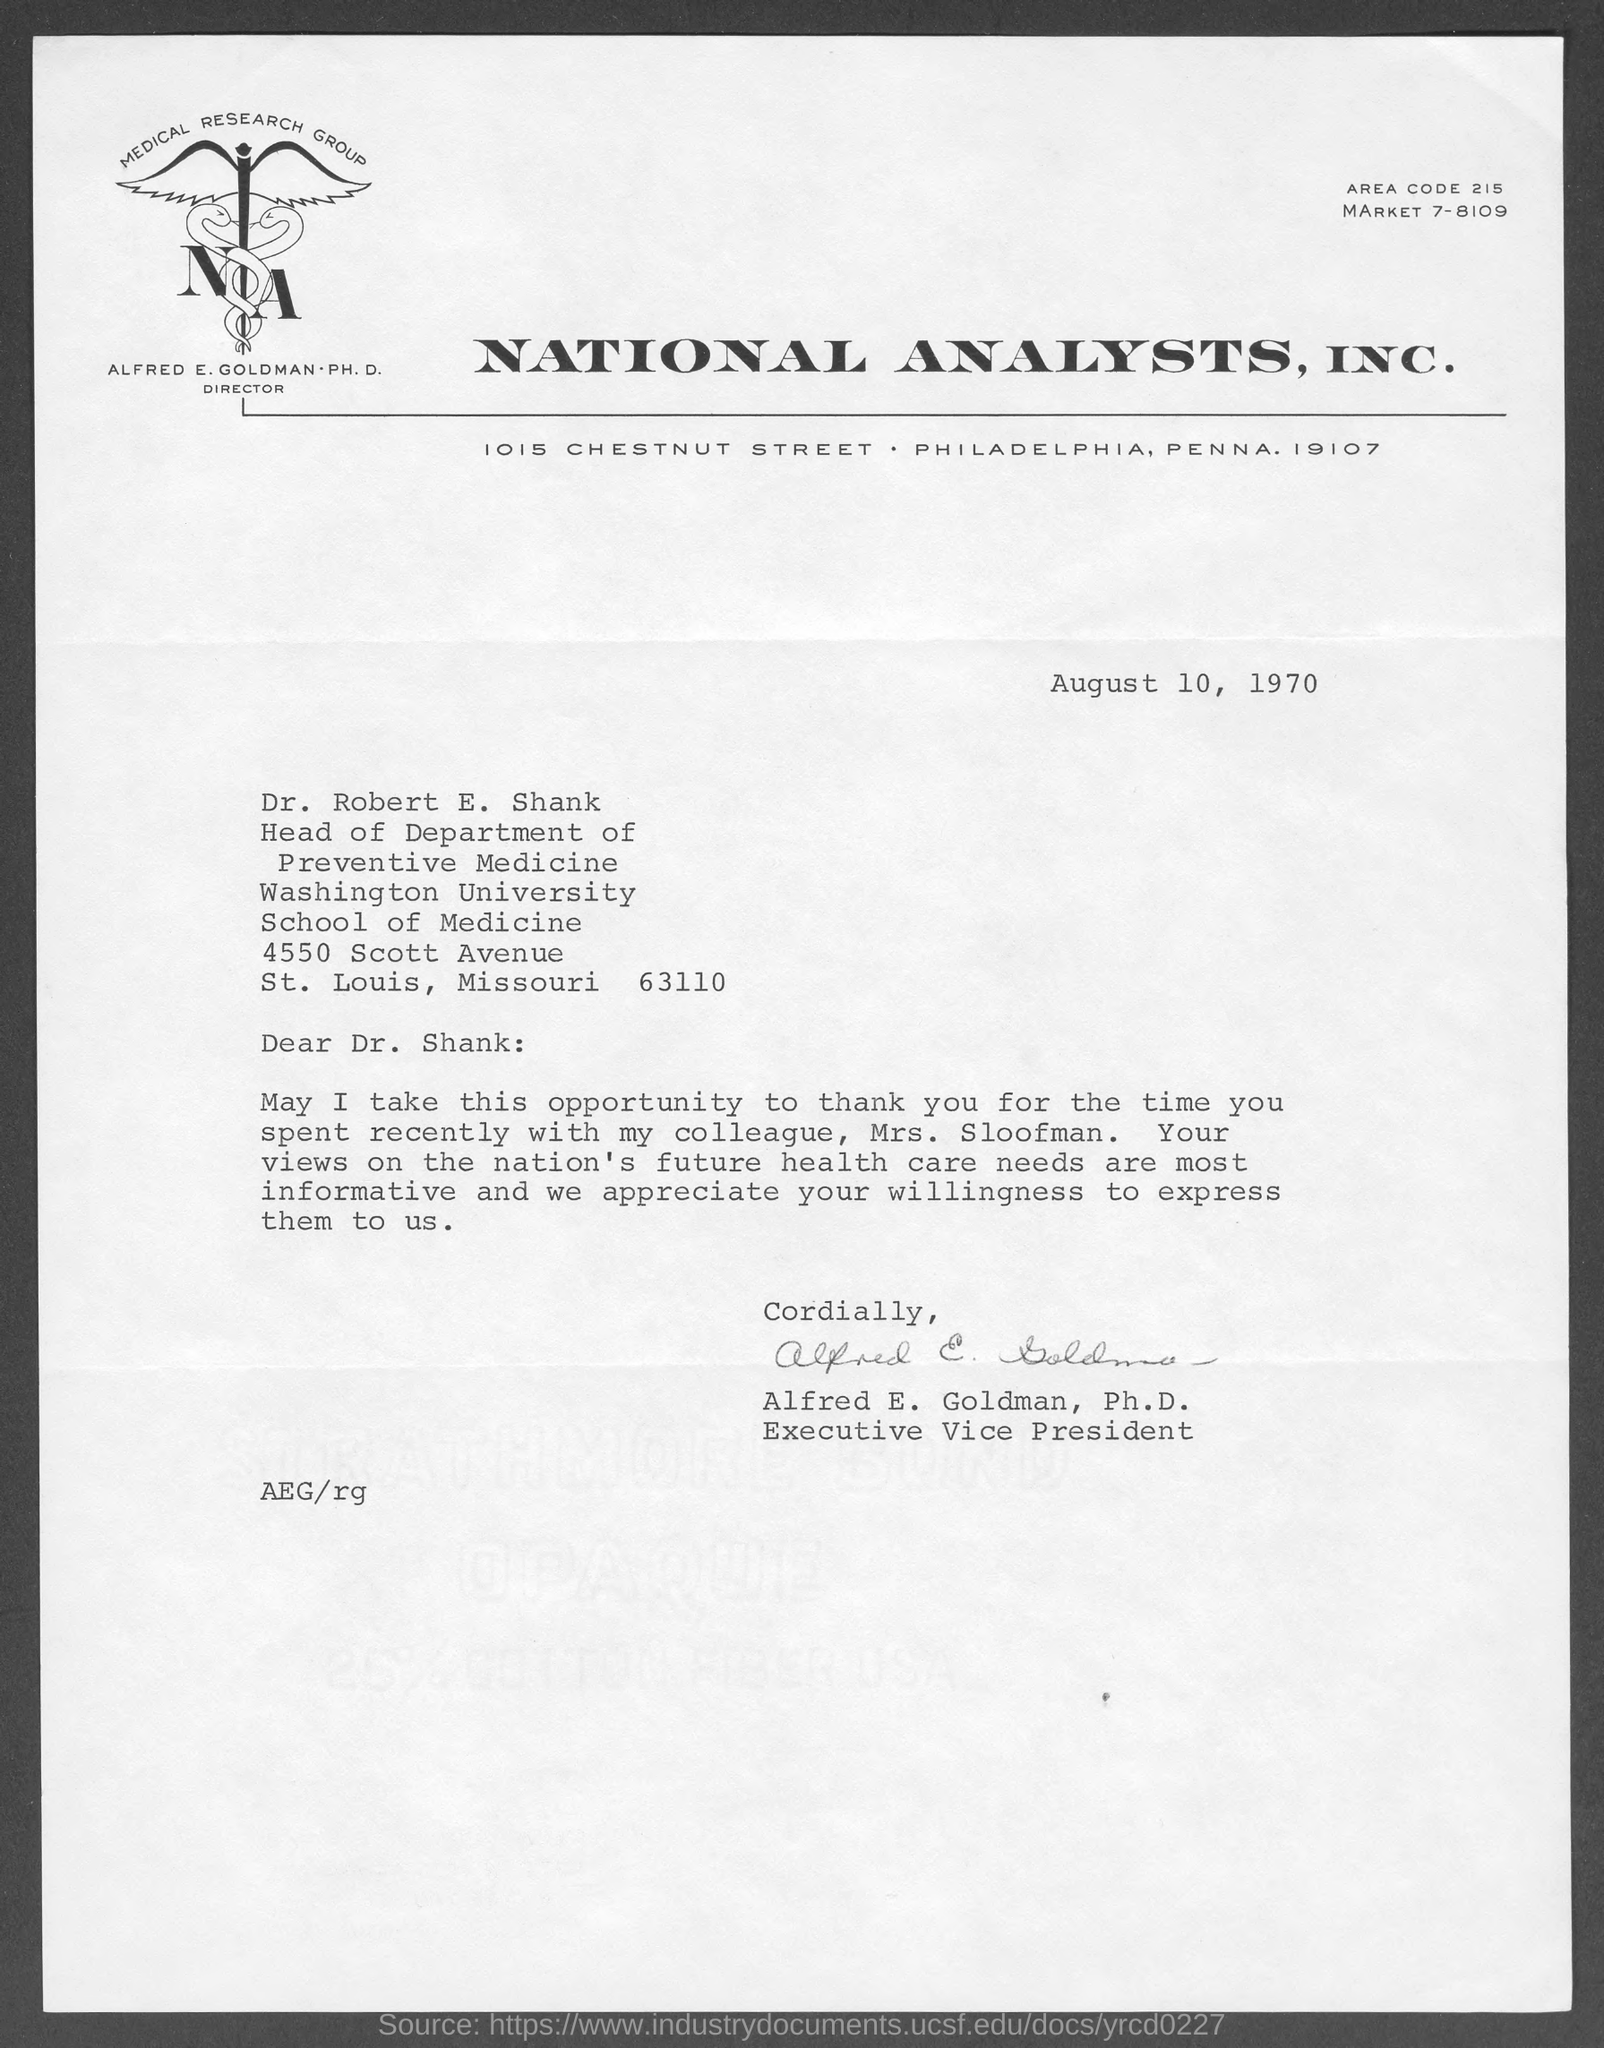Which firm is mentioned at the top of the page?
Keep it short and to the point. NATIONAL ANALYSTS, INC. What is the area code?
Keep it short and to the point. 215. When is the document dated?
Offer a terse response. August 10, 1970. To whom is the letter addressed?
Give a very brief answer. Dr. Shank. Who is the sender?
Provide a short and direct response. Alfred e. goldman. 